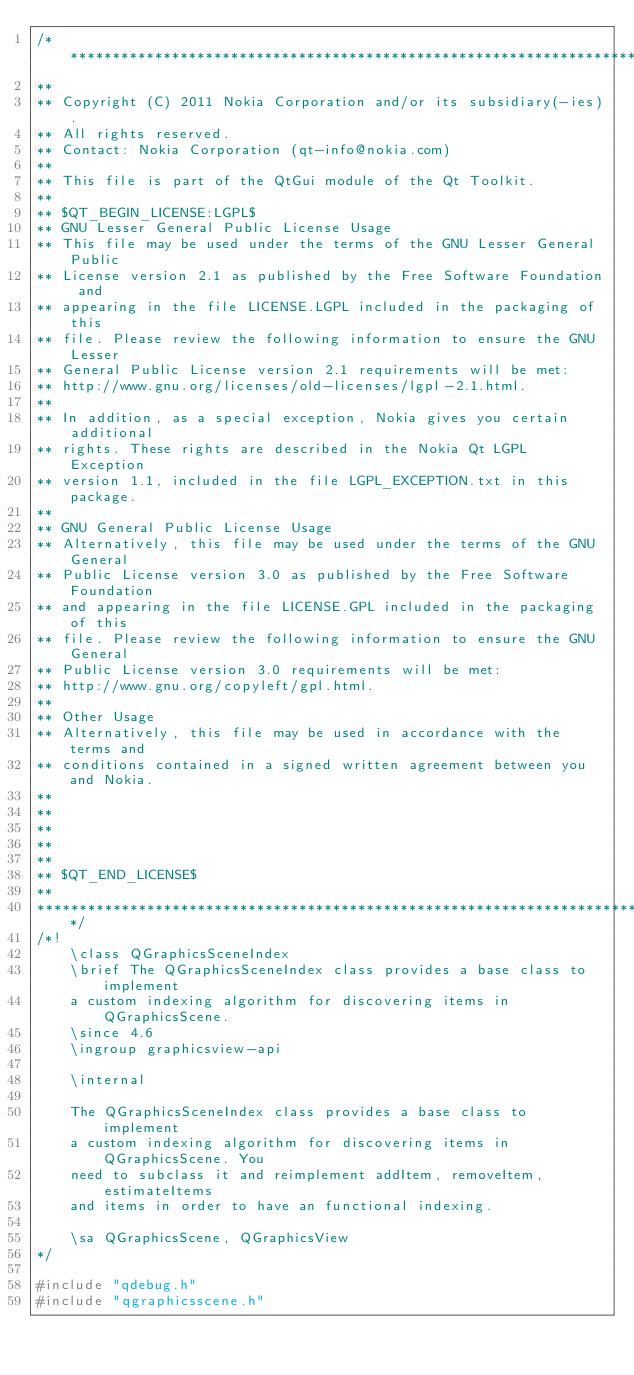Convert code to text. <code><loc_0><loc_0><loc_500><loc_500><_C++_>/****************************************************************************
**
** Copyright (C) 2011 Nokia Corporation and/or its subsidiary(-ies).
** All rights reserved.
** Contact: Nokia Corporation (qt-info@nokia.com)
**
** This file is part of the QtGui module of the Qt Toolkit.
**
** $QT_BEGIN_LICENSE:LGPL$
** GNU Lesser General Public License Usage
** This file may be used under the terms of the GNU Lesser General Public
** License version 2.1 as published by the Free Software Foundation and
** appearing in the file LICENSE.LGPL included in the packaging of this
** file. Please review the following information to ensure the GNU Lesser
** General Public License version 2.1 requirements will be met:
** http://www.gnu.org/licenses/old-licenses/lgpl-2.1.html.
**
** In addition, as a special exception, Nokia gives you certain additional
** rights. These rights are described in the Nokia Qt LGPL Exception
** version 1.1, included in the file LGPL_EXCEPTION.txt in this package.
**
** GNU General Public License Usage
** Alternatively, this file may be used under the terms of the GNU General
** Public License version 3.0 as published by the Free Software Foundation
** and appearing in the file LICENSE.GPL included in the packaging of this
** file. Please review the following information to ensure the GNU General
** Public License version 3.0 requirements will be met:
** http://www.gnu.org/copyleft/gpl.html.
**
** Other Usage
** Alternatively, this file may be used in accordance with the terms and
** conditions contained in a signed written agreement between you and Nokia.
**
**
**
**
**
** $QT_END_LICENSE$
**
****************************************************************************/
/*!
    \class QGraphicsSceneIndex
    \brief The QGraphicsSceneIndex class provides a base class to implement
    a custom indexing algorithm for discovering items in QGraphicsScene.
    \since 4.6
    \ingroup graphicsview-api

    \internal

    The QGraphicsSceneIndex class provides a base class to implement
    a custom indexing algorithm for discovering items in QGraphicsScene. You
    need to subclass it and reimplement addItem, removeItem, estimateItems
    and items in order to have an functional indexing.

    \sa QGraphicsScene, QGraphicsView
*/

#include "qdebug.h"
#include "qgraphicsscene.h"</code> 